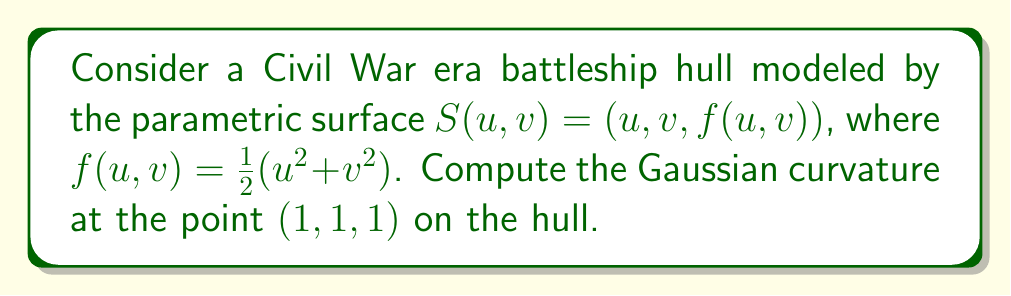Teach me how to tackle this problem. To compute the Gaussian curvature, we'll follow these steps:

1) The Gaussian curvature K is given by $K = \frac{LN - M^2}{EG - F^2}$, where E, F, G are the coefficients of the first fundamental form, and L, M, N are the coefficients of the second fundamental form.

2) First, let's calculate the partial derivatives:
   $S_u = (1, 0, u)$
   $S_v = (0, 1, v)$
   $S_{uu} = (0, 0, 1)$
   $S_{vv} = (0, 0, 1)$
   $S_{uv} = (0, 0, 0)$

3) The unit normal vector is:
   $\vec{N} = \frac{S_u \times S_v}{|S_u \times S_v|} = \frac{(-u, -v, 1)}{\sqrt{u^2 + v^2 + 1}}$

4) Now we can calculate E, F, G:
   $E = S_u \cdot S_u = 1 + u^2$
   $F = S_u \cdot S_v = uv$
   $G = S_v \cdot S_v = 1 + v^2$

5) And L, M, N:
   $L = S_{uu} \cdot \vec{N} = \frac{1}{\sqrt{u^2 + v^2 + 1}}$
   $M = S_{uv} \cdot \vec{N} = 0$
   $N = S_{vv} \cdot \vec{N} = \frac{1}{\sqrt{u^2 + v^2 + 1}}$

6) Now we can compute K:
   $K = \frac{LN - M^2}{EG - F^2} = \frac{\frac{1}{u^2 + v^2 + 1}}{(1+u^2)(1+v^2) - u^2v^2}$

7) At the point (1,1,1), u = 1 and v = 1. Substituting these values:
   $K = \frac{\frac{1}{1^2 + 1^2 + 1}}{(1+1^2)(1+1^2) - 1^2 \cdot 1^2} = \frac{1/3}{4 - 1} = \frac{1}{9}$
Answer: $\frac{1}{9}$ 